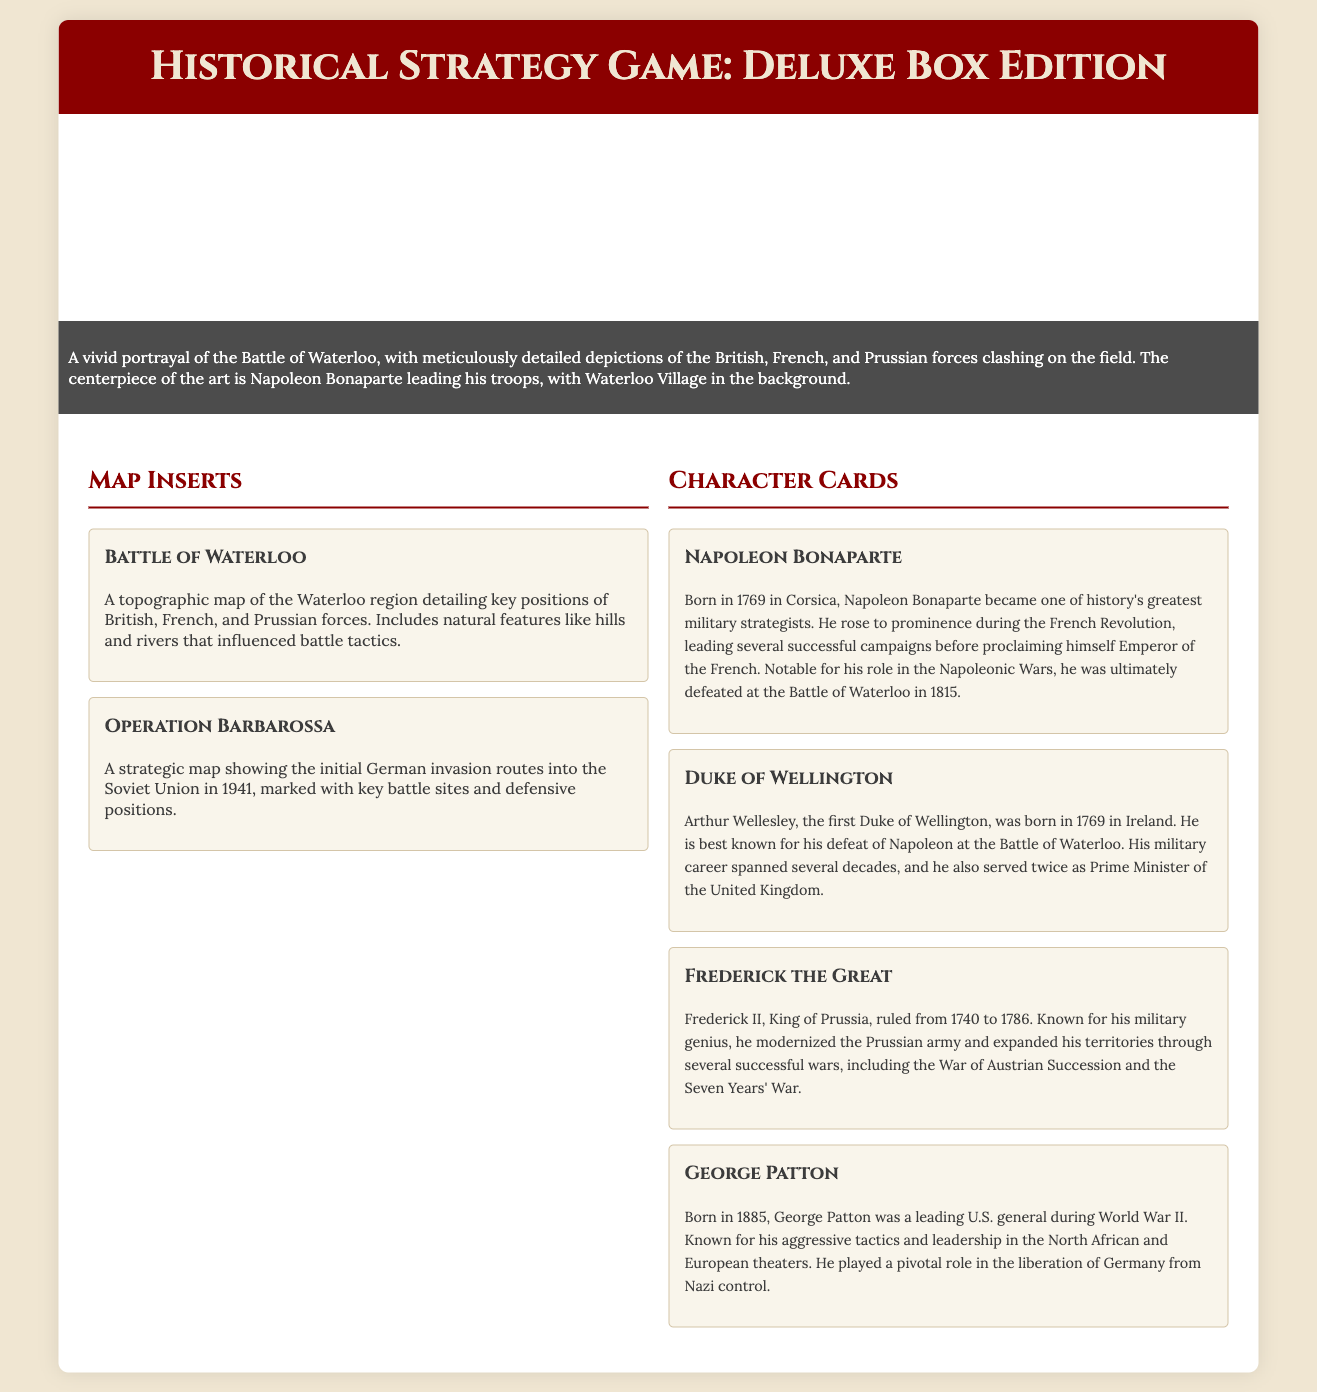What is depicted in the box art? The box art depicts a vivid portrayal of the Battle of Waterloo, emphasizing Napoleon Bonaparte leading his troops.
Answer: Battle of Waterloo What are the two main types of inserts included in the Deluxe Box Edition? The inserts include map inserts and character cards, each serving different gameplay purposes.
Answer: Map inserts and character cards Who was the first Duke of Wellington? The first Duke of Wellington, prominent for his military leadership, was Arthur Wellesley.
Answer: Arthur Wellesley In what year was Napoleon Bonaparte defeated at the Battle of Waterloo? The document states that Napoleon was defeated at the Battle of Waterloo in 1815.
Answer: 1815 What major historical event do the map inserts for Operation Barbarossa detail? The map inserts detail the initial German invasion routes into the Soviet Union in 1941.
Answer: Operation Barbarossa What is the birth year of George Patton? According to the character cards, George Patton was born in 1885.
Answer: 1885 What type of game does the packaging promote? The packaging promotes a historical strategy game, which focuses on tactics and historical battles.
Answer: Historical strategy game How many character cards are mentioned in the document? The document lists four character cards featuring notable historical figures.
Answer: Four character cards What is the main purpose of the map inserts? The map inserts are designed for in-game strategy planning, influencing tactics during gameplay.
Answer: In-game strategy planning 